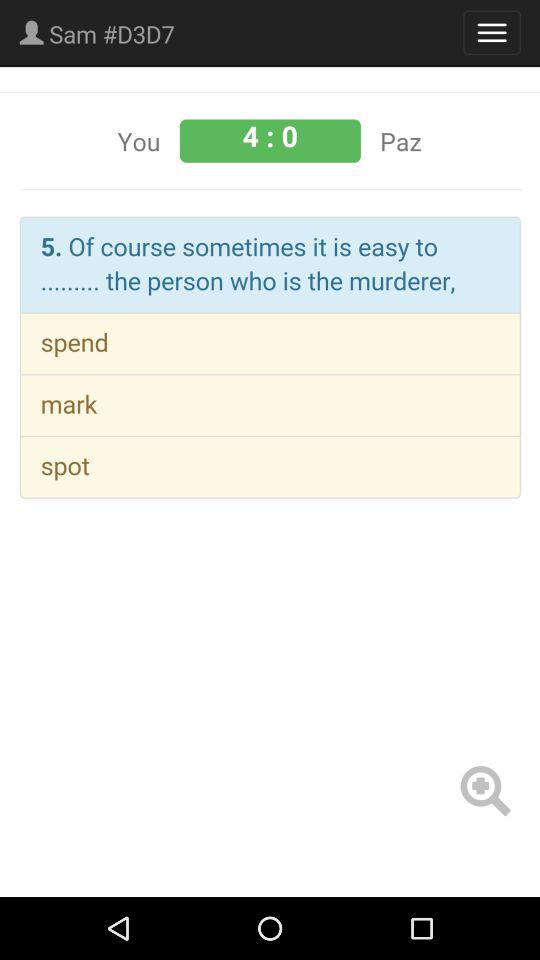What is the score between me and Paz? The score between me and Paz is 4:0. 